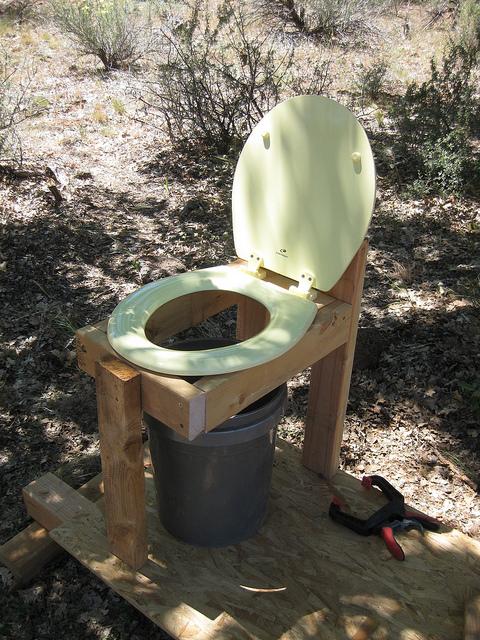What is position under the toilet seat?
Short answer required. Bucket. What is this for?
Quick response, please. Going to bathroom. Where would you normally find this object?
Be succinct. Bathroom. 